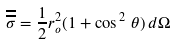Convert formula to latex. <formula><loc_0><loc_0><loc_500><loc_500>\overline { \overline { \sigma } } = \frac { 1 } { 2 } r _ { o } ^ { 2 } ( 1 + \cos ^ { \, 2 } \, \theta ) \, d \Omega</formula> 